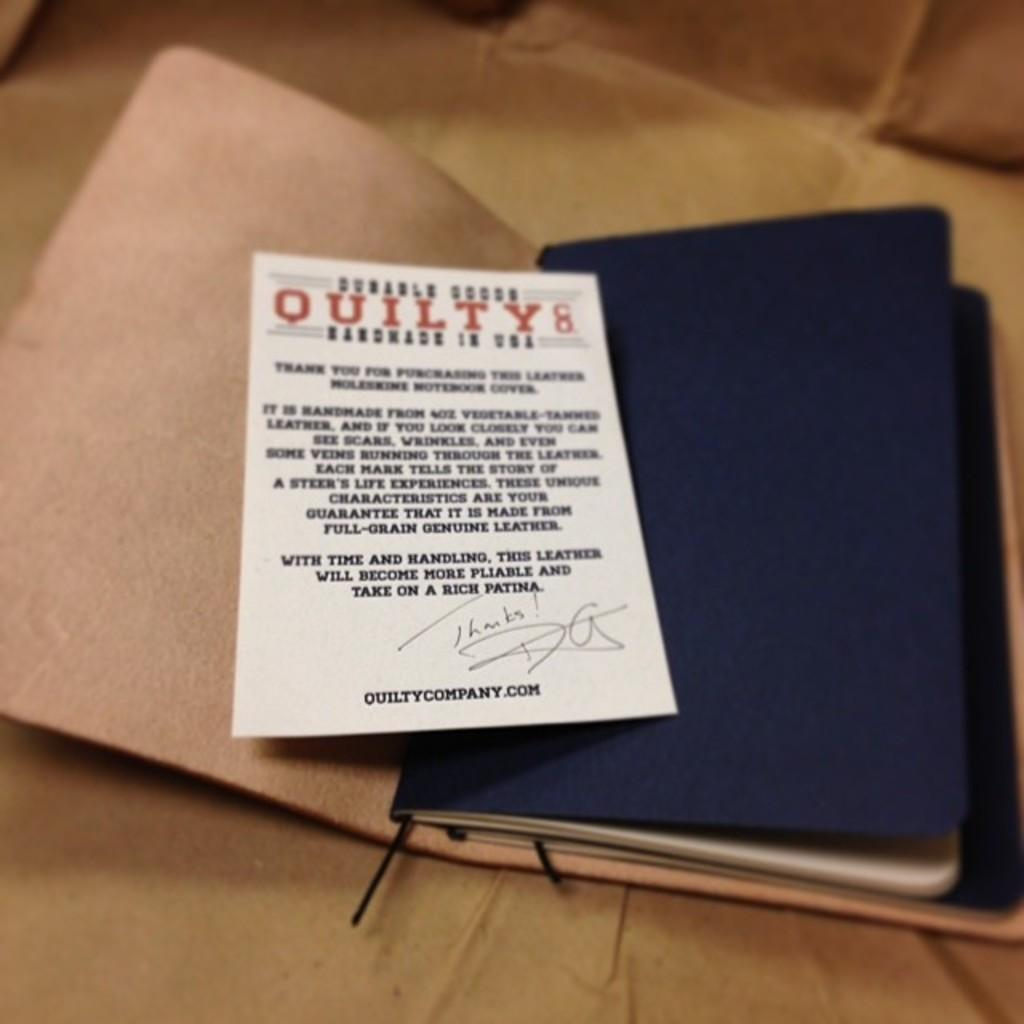<image>
Provide a brief description of the given image. a paper on top of a booklet that says quilty on it in red 